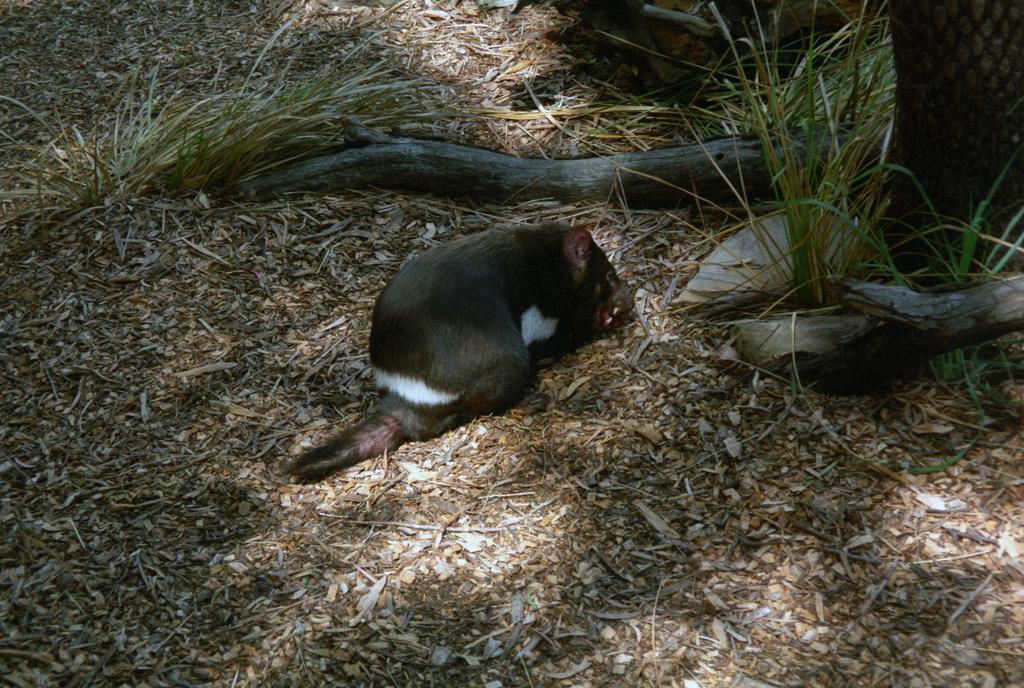Describe this image in one or two sentences. In the middle I can see a mouse on the ground. In the background I can see grass, wood and plants. This image is taken during a day on the ground. 